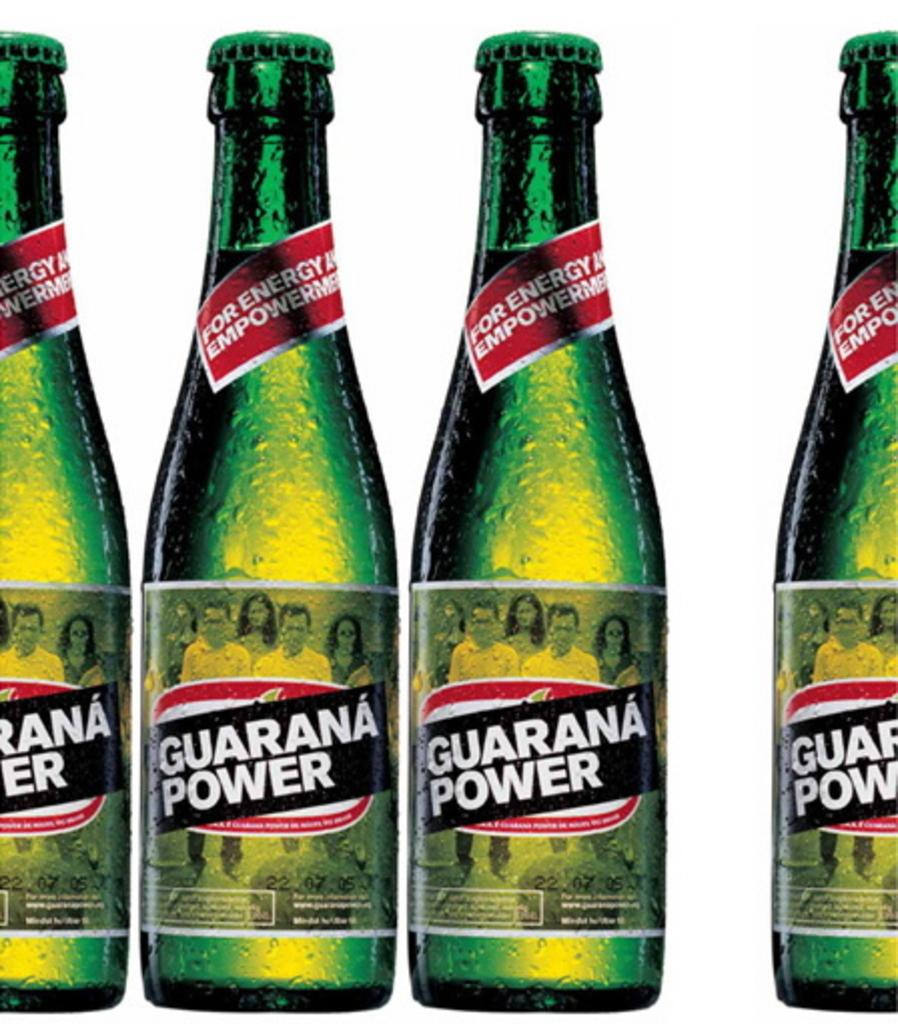Provide a one-sentence caption for the provided image. An advertisement for a green bottle drink that says Guarana Power on the label. 